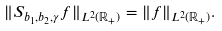<formula> <loc_0><loc_0><loc_500><loc_500>\| S _ { b _ { 1 } , b _ { 2 } , \gamma } f \| _ { L ^ { 2 } ( \mathbb { R } _ { + } ) } = \| f \| _ { L ^ { 2 } ( \mathbb { R } _ { + } ) } .</formula> 